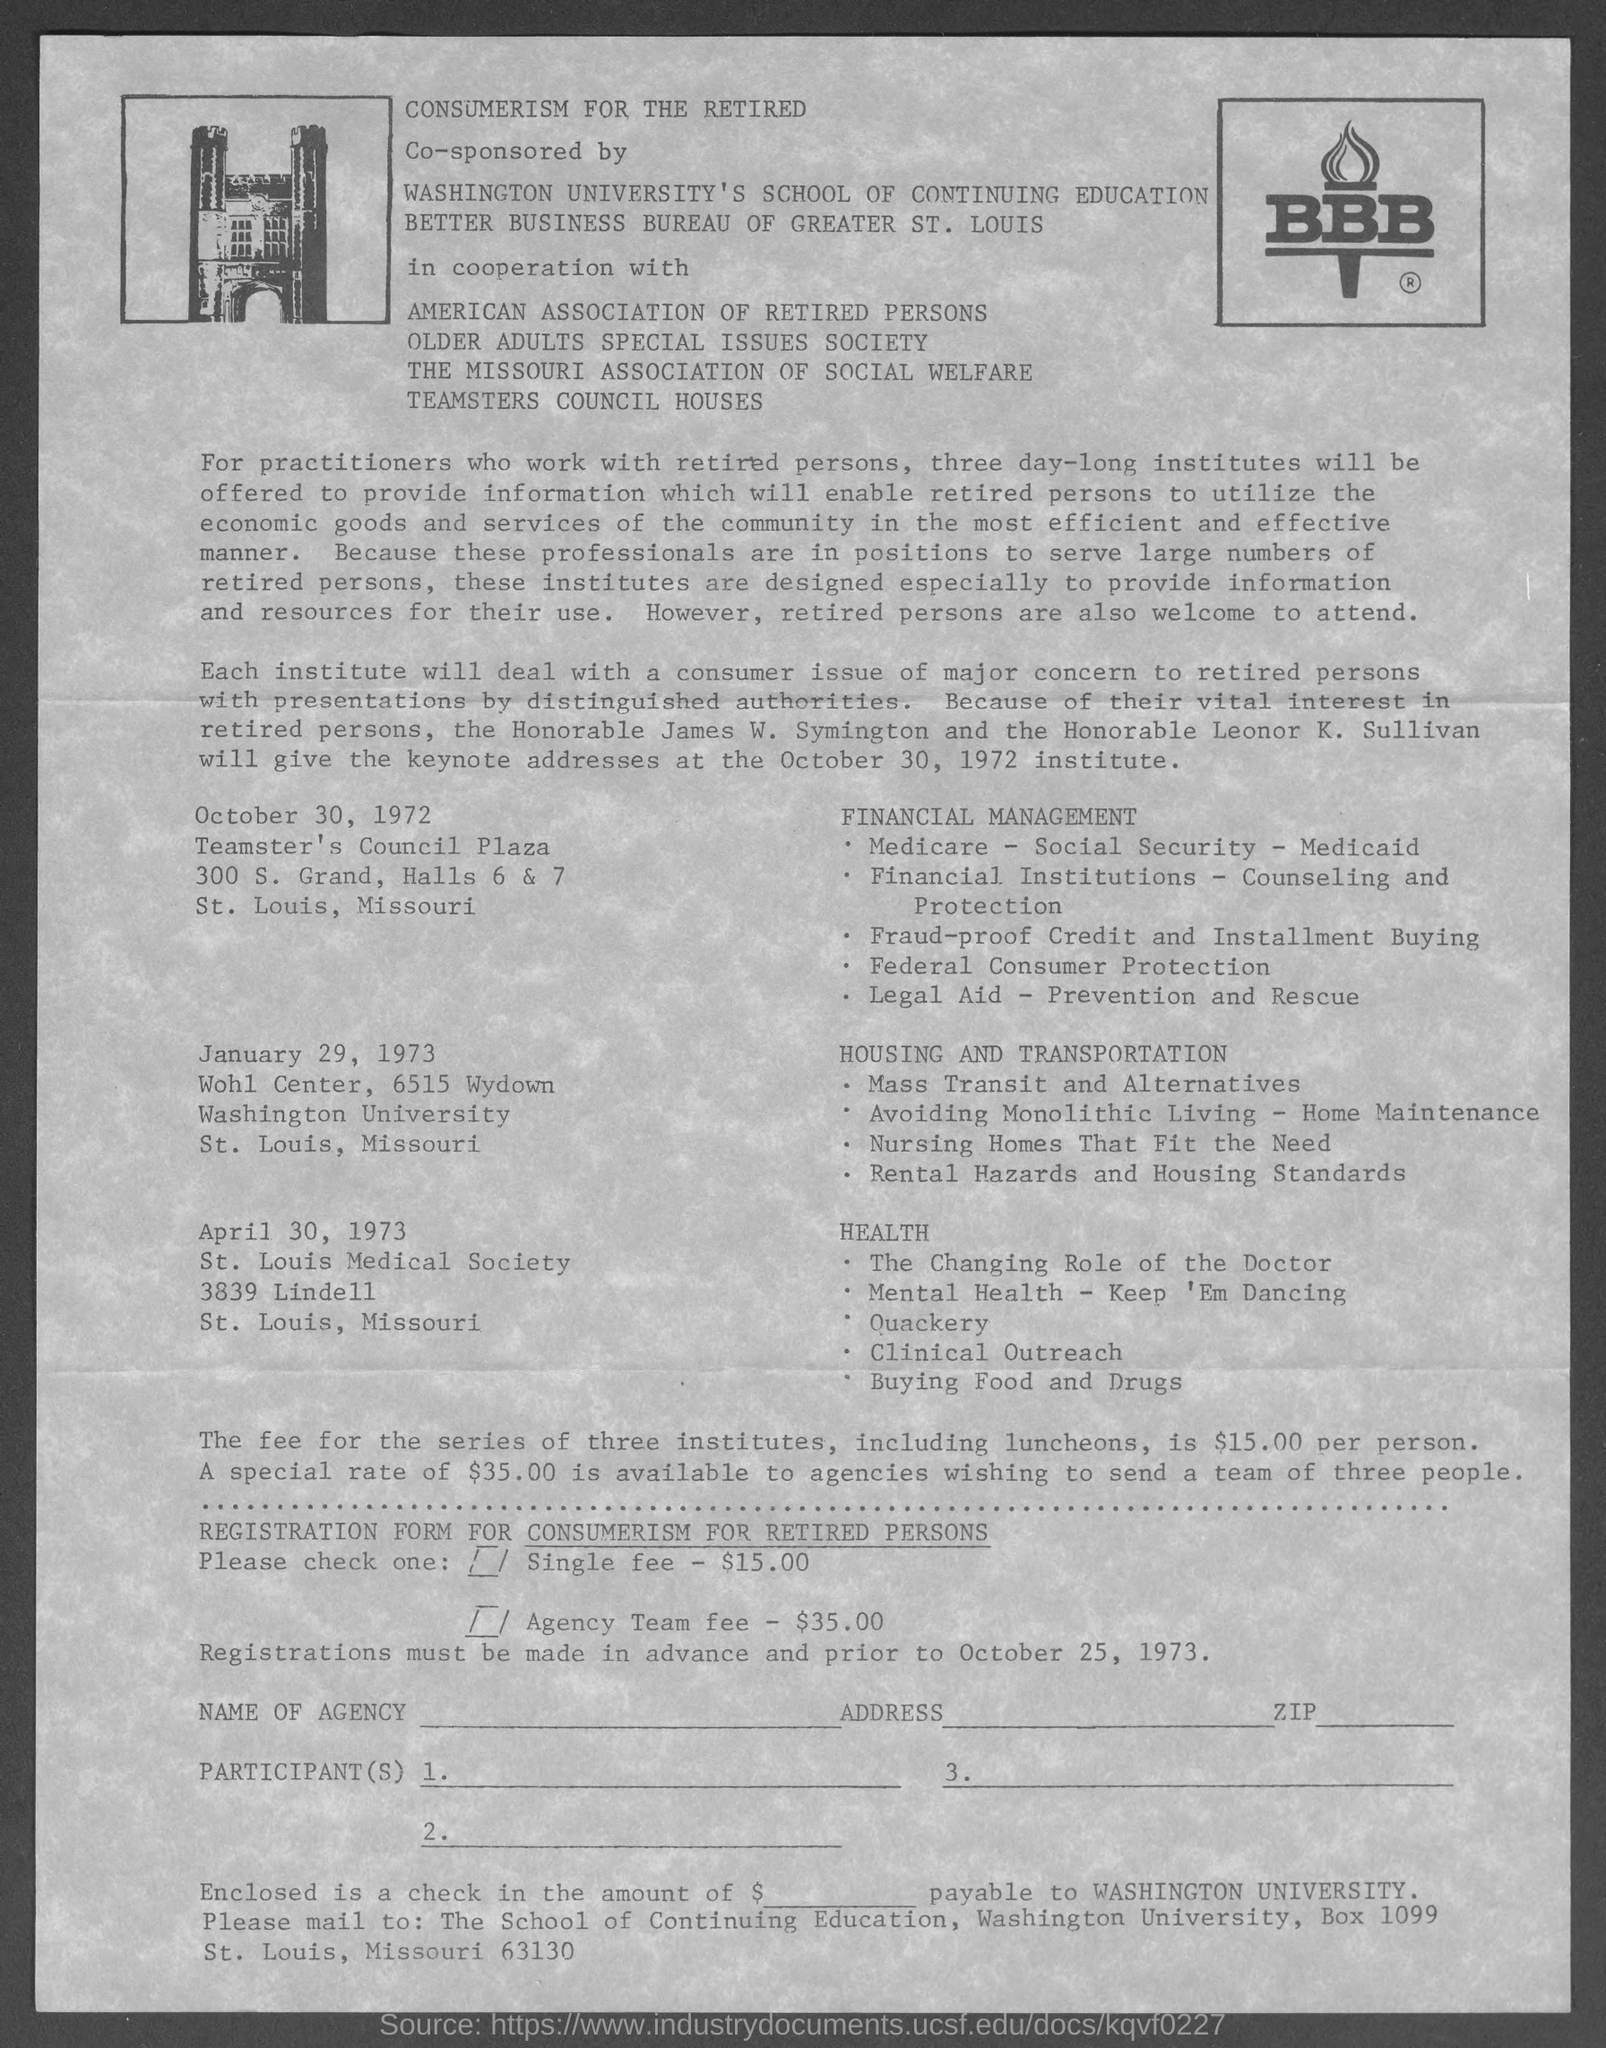What is the Single fee?
Give a very brief answer. $15.00. What is the Agency Team Fee?
Ensure brevity in your answer.  $35.00. 